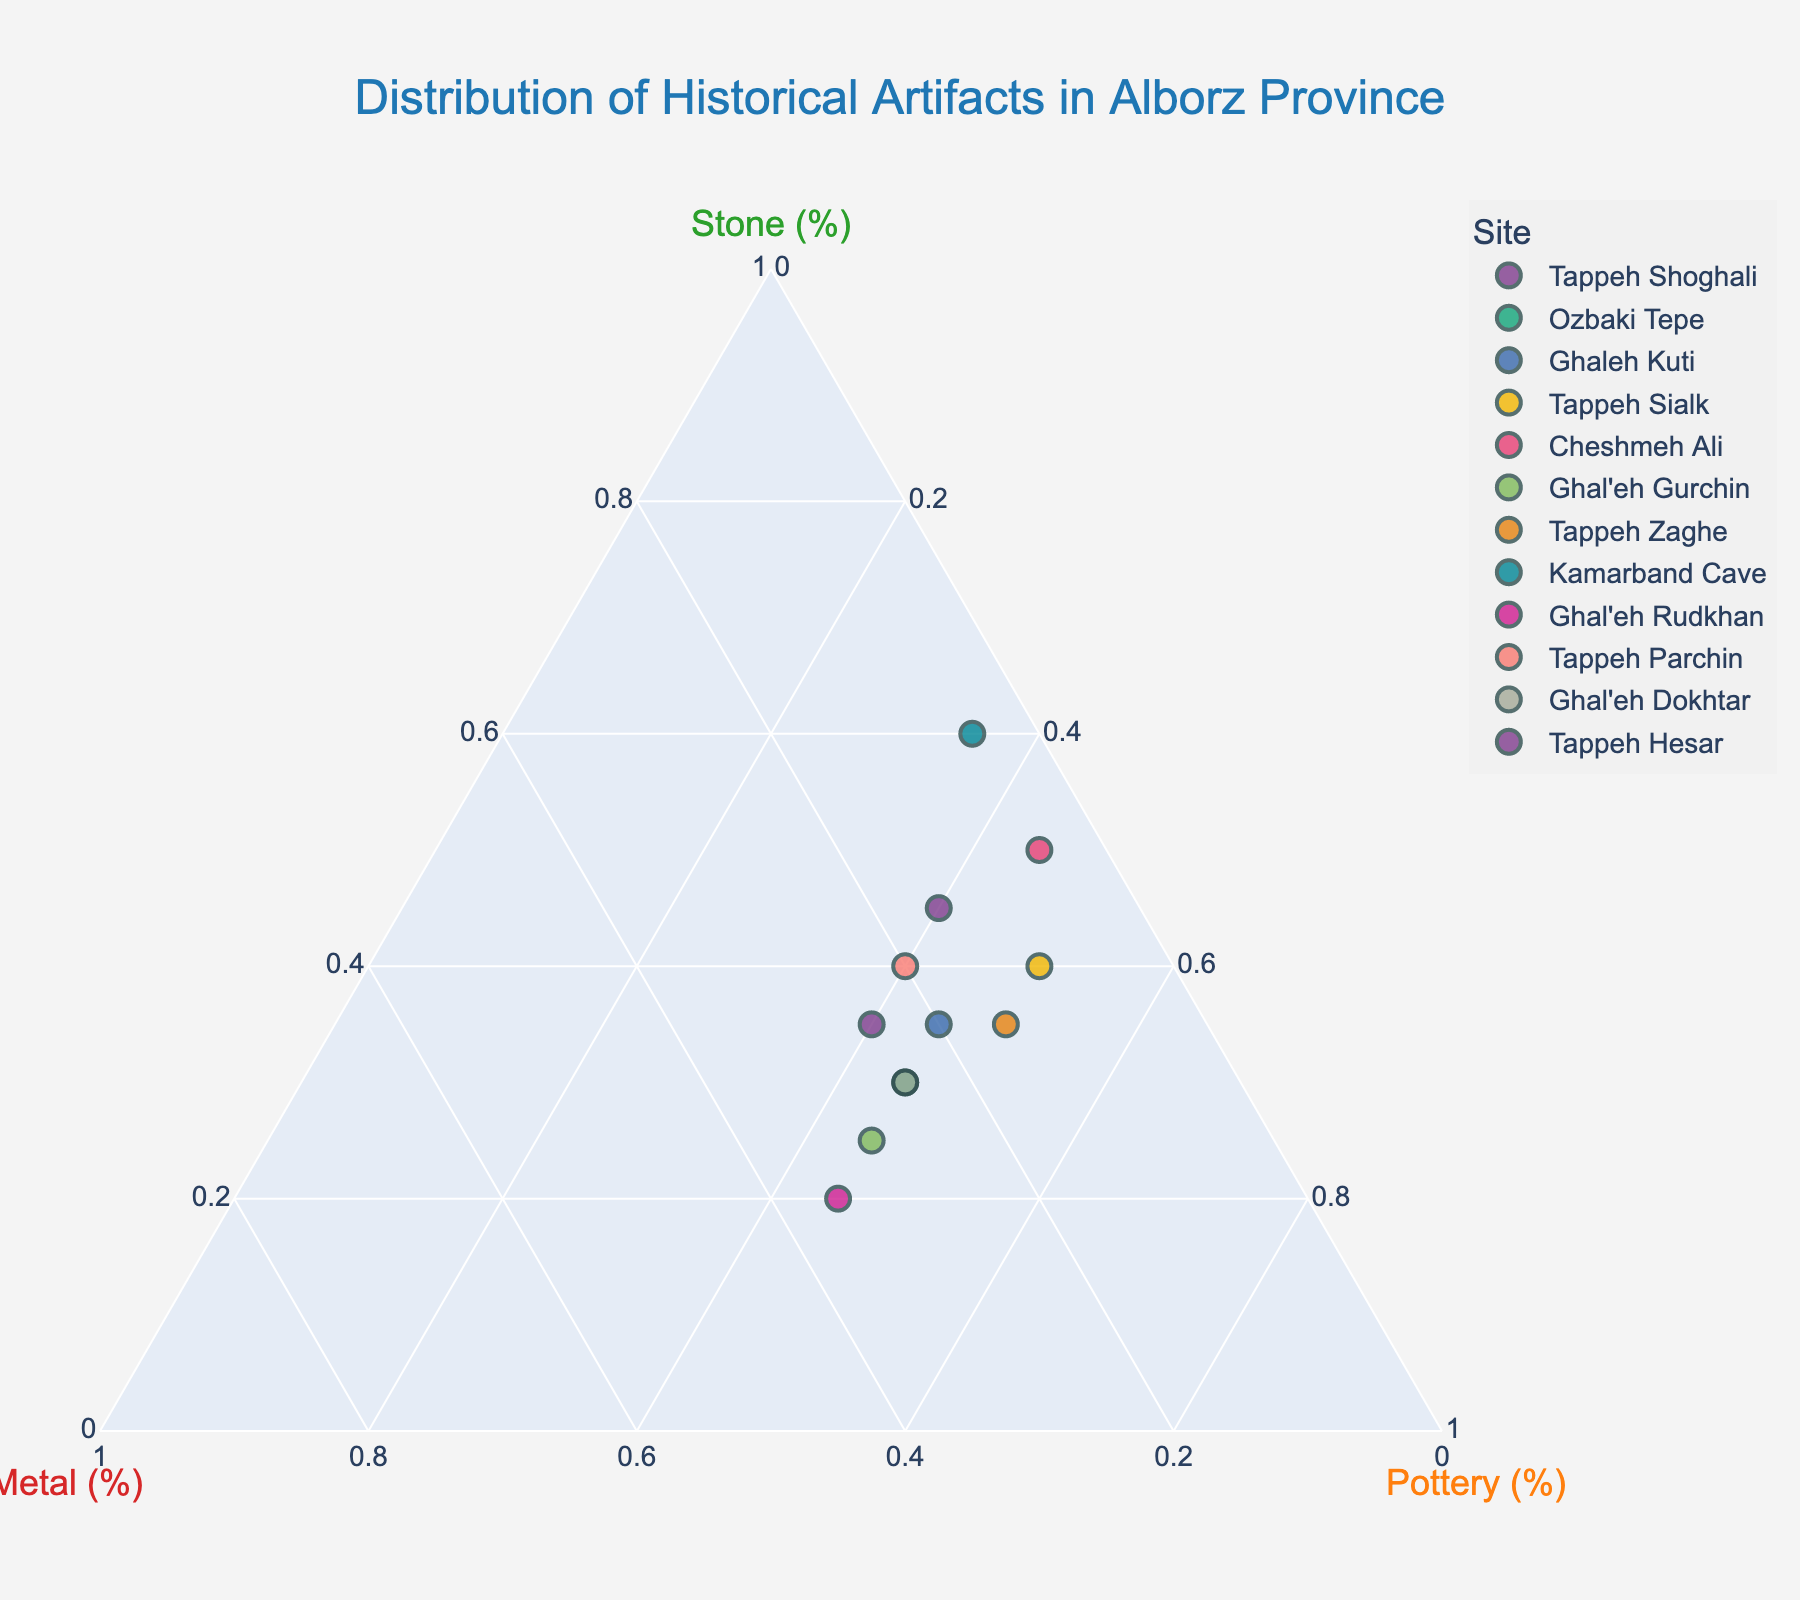How many sites are represented on the ternary plot? Count all the distinct data points on the plot. Each data point represents a unique site.
Answer: 12 Which site has the highest percentage of stone artifacts? Identify the data point closest to the "Stone" axis. The axis represents the percentage of stone artifacts.
Answer: Kamarband Cave What is the percentage of metal artifacts in Tappeh Parchin? Locate the data point for Tappeh Parchin, and read off the percentage corresponding to the "Metal" axis.
Answer: 20% Which site has an equal percentage of metal and pottery artifacts? Find the data point where the values of metal and pottery are the same. This point lies midway between the "Metal" and "Pottery" axes.
Answer: None What is the average percentage of stone artifacts across all sites? Sum the percentages of stone artifacts for all sites and then divide by the number of sites: (45 + 30 + 35 + 40 + 50 + 25 + 35 + 60 + 20 + 40 + 30 + 35) / 12 = 35.8%
Answer: 35.8% Which site has the closest distribution of artifacts across stone, metal, and pottery? Identify the data point that lies closest to the center of the ternary plot, indicating an even distribution among the three categories.
Answer: Ghaleh Kuti Between Ghal'eh Rudkhan and Cheshmeh Ali, which site has a higher percentage of metal artifacts? Compare the percentage of metal artifacts for both sites by locating their respective data points. Ghal'eh Rudkhan has 35% and Cheshmeh Ali has 5%.
Answer: Ghal'eh Rudkhan If you combine the stone artifacts from Tappeh Zaghe and Ghal'eh Dokhtar, what is the total percentage? Add the percentages of stone artifacts from both sites: 35% (Tappeh Zaghe) + 30% (Ghal'eh Dokhtar) = 65%
Answer: 65% Which site has the highest percentage of pottery artifacts? Identify the data point closest to the "Pottery" axis. The axis represents the percentage of pottery artifacts.
Answer: Tappeh Sialk What is the sum of the metal artifact percentages for Ghal'eh Gurchin and Tappeh Hesar? Add the percentages of metal artifacts for both sites: 30% (Ghal'eh Gurchin) + 25% (Tappeh Hesar) = 55%
Answer: 55% 